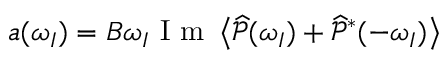Convert formula to latex. <formula><loc_0><loc_0><loc_500><loc_500>a ( \omega _ { I } ) = B \omega _ { I } I m \left < \widehat { \mathcal { P } } ( \omega _ { I } ) + \widehat { \mathcal { P } } ^ { * } ( - \omega _ { I } ) \right ></formula> 